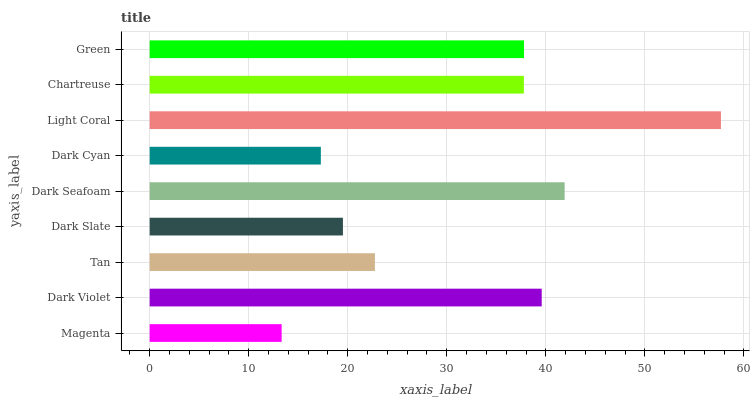Is Magenta the minimum?
Answer yes or no. Yes. Is Light Coral the maximum?
Answer yes or no. Yes. Is Dark Violet the minimum?
Answer yes or no. No. Is Dark Violet the maximum?
Answer yes or no. No. Is Dark Violet greater than Magenta?
Answer yes or no. Yes. Is Magenta less than Dark Violet?
Answer yes or no. Yes. Is Magenta greater than Dark Violet?
Answer yes or no. No. Is Dark Violet less than Magenta?
Answer yes or no. No. Is Chartreuse the high median?
Answer yes or no. Yes. Is Chartreuse the low median?
Answer yes or no. Yes. Is Light Coral the high median?
Answer yes or no. No. Is Magenta the low median?
Answer yes or no. No. 